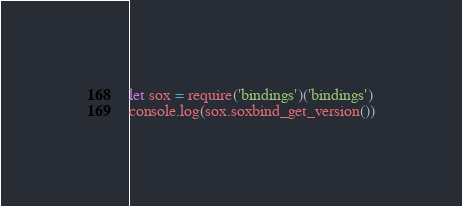<code> <loc_0><loc_0><loc_500><loc_500><_JavaScript_>let sox = require('bindings')('bindings')
console.log(sox.soxbind_get_version())
</code> 